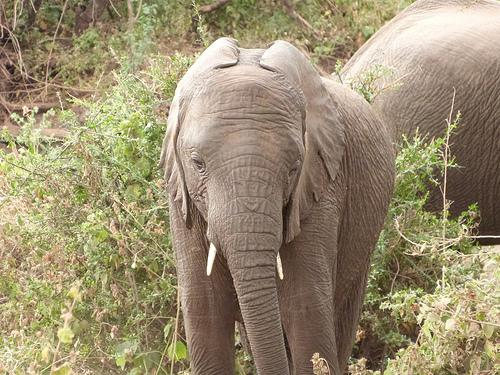What is the main animal depicted in the image, along with its color? A grey baby elephant. Identify the objects related to plant life in the image. Leaves, green bushes, green grass, branches, and twigs. Which body parts of the baby elephant are described from the left and right sides? Left side: tusk; right side: ear. Give a brief overview of the primary elements in the image. A grey baby elephant with various body parts labeled, including eyes, tusks, trunk, legs, and ears, as well as surrounding green bushes, grass, and branches. Quantify the occurrence of different components of the elephant body in the image. Two eyes, two ears, six legs, three trunks, and two tusks. Describe the position and visual interaction between the baby elephant and the large elephant. The large elephant is positioned behind the baby elephant. Analyze the setting by describing the natural elements and their key features. Wooded area with big green bushes, green grass, green leaves on the bush, and grey twigs. How many tusks are in the image and what is their general size? There are 11 tusks, and most of them are small in size. What emotions and attributes are connected to the baby elephant in the image captions? Sadness, grey color, small size, and wrinkled skin. 